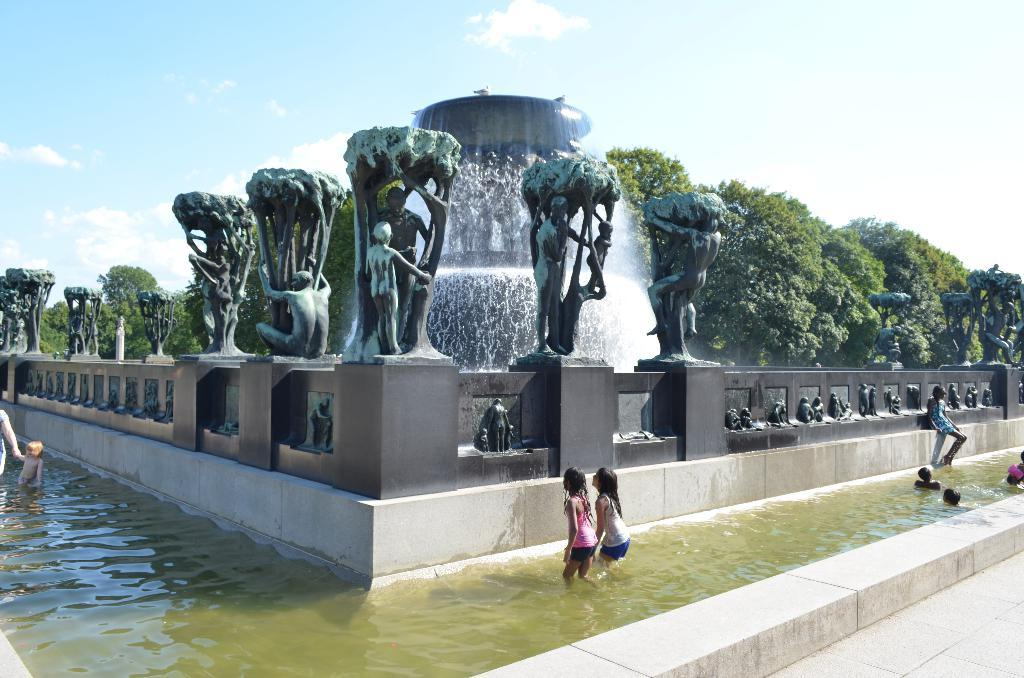What is the main feature in the picture? There is a fountain in the picture. What are the kids doing near the fountain? The kids are playing in the water. Are there any other objects or structures in the picture? Yes, there are statues in the picture. What can be seen in the background of the picture? Trees are visible in the backdrop of the picture. How is the weather in the picture? The sky is clear in the picture, suggesting good weather. How many cows are grazing near the fountain in the picture? There are no cows present in the picture; it features a fountain with kids playing in the water and statues. What is the wealth status of the people in the picture? There is no information about the wealth status of the people in the picture, as it only shows a fountain, kids playing, statues, trees, and a clear sky. 